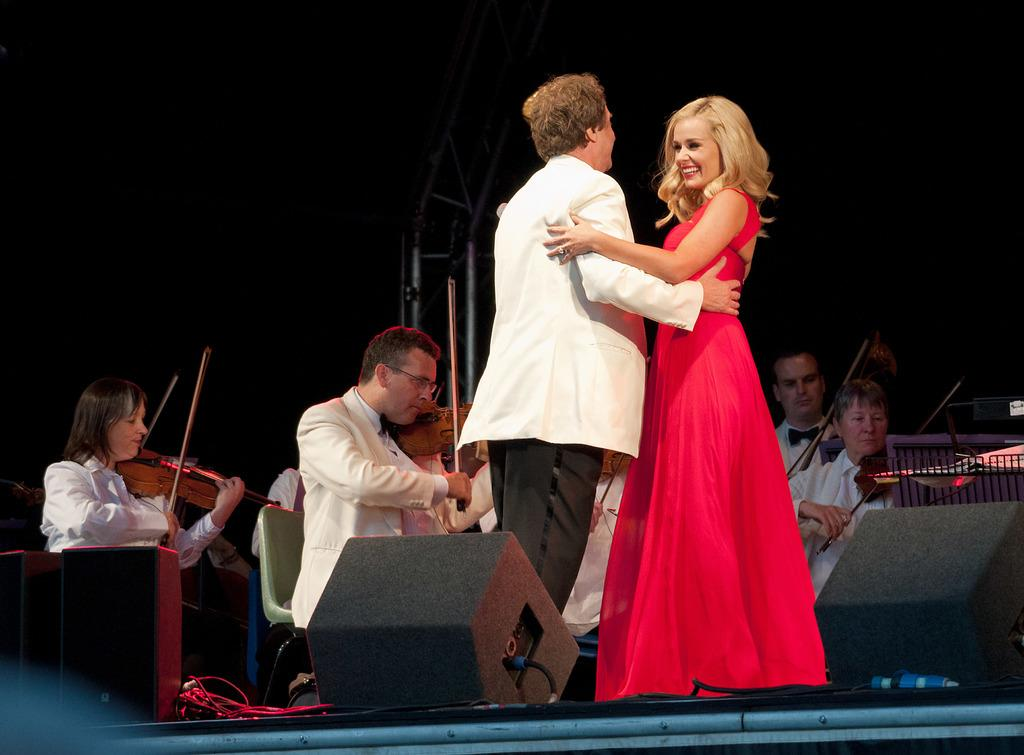What activity are the people in the image engaged in? The group of people in the image is playing a violin. Can you describe the woman in the image? There is a woman in the image, and she is wearing a red dress. What expression does the woman have? The woman is smiling. Can you see any stars in the image? There are no stars visible in the image. Is there a snail crawling on the woman's red dress in the image? There is no snail present in the image. 